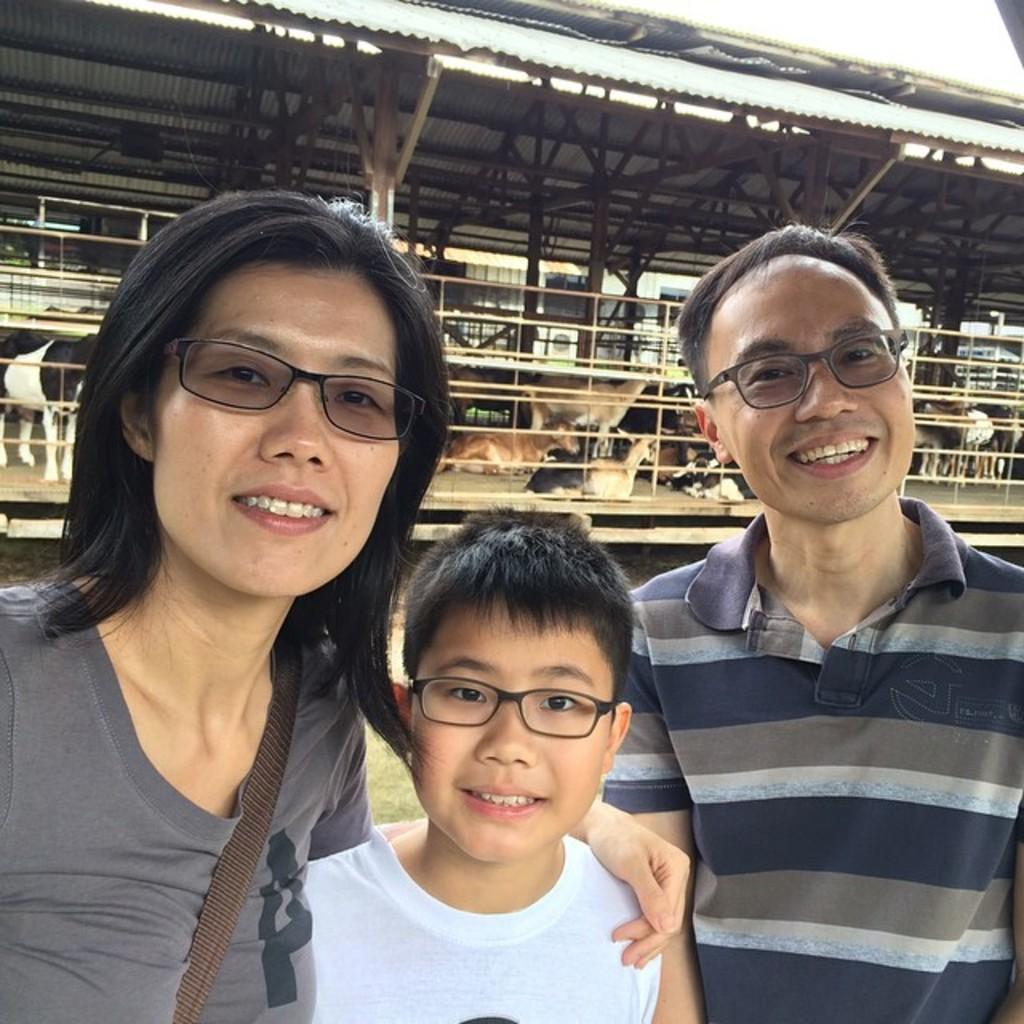How many people are in the image? There are three people in the image. What are the people wearing? The people are wearing spectacles. What expression do the people have? The people are smiling. What type of structure is visible in the image? There is an open shed in the image. What can be found under the shed? There are animals under the shed. How many fans are visible in the image? There are no fans present in the image. Are there any children visible in the image? The provided facts do not mention any children in the image. 